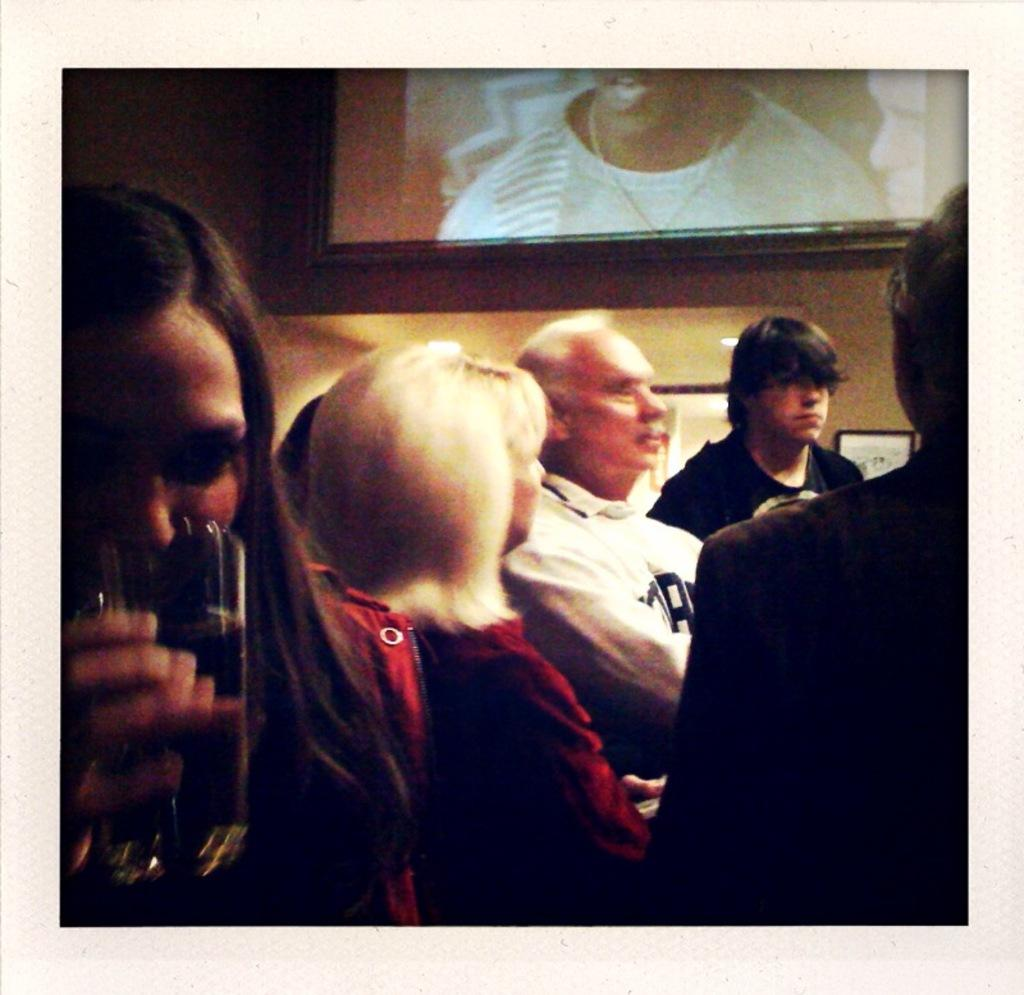How many people are in the image? There is a group of people in the image. What is one person in the group holding? One person is holding a glass in the image. What can be seen in the background of the image? There is a screen visible in the background of the image. Can you see a bear interacting with the group of people in the image? No, there is no bear present in the image. What type of angle is the camera positioned at in the image? The facts provided do not give information about the camera angle, so it cannot be determined from the image. 